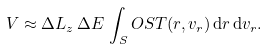<formula> <loc_0><loc_0><loc_500><loc_500>V \approx \Delta L _ { z } \, \Delta E \, \int _ { S } O S T ( r , v _ { r } ) \, { \mathrm d } r \, { \mathrm d } v _ { r } .</formula> 